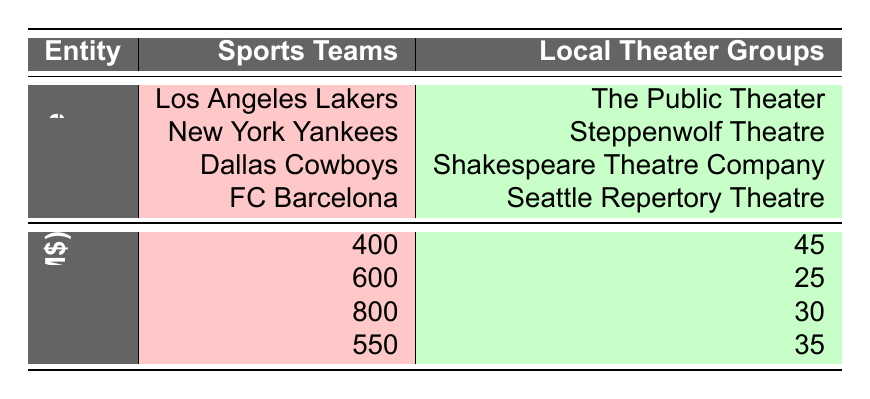What is the revenue of the New York Yankees in 2022? The table lists the revenue for each sports team, including the New York Yankees, which is shown as 600 million.
Answer: 600 million Which local theater group had the highest revenue in 2022? By examining the revenue values of local theater groups, The Public Theater has the highest revenue, totaling 45 million.
Answer: The Public Theater What is the combined revenue of the Dallas Cowboys and FC Barcelona? The revenue for the Dallas Cowboys is 800 million and for FC Barcelona is 550 million. Adding these gives 800 + 550 = 1350 million.
Answer: 1350 million Is the revenue of Steppenwolf Theatre greater than 30 million? The table shows the revenue for Steppenwolf Theatre as 25 million, which is less than 30 million. Thus, the answer is false.
Answer: False What is the average revenue of all sports teams listed? There are four sports teams with revenues of 400, 600, 800, and 550 million. The sum is 400 + 600 + 800 + 550 = 2350 million, and then dividing by 4, the average is 2350 / 4 = 587.5 million.
Answer: 587.5 million Which sports team has the largest revenue among the listed teams? By reviewing the revenues, the Dallas Cowboys at 800 million are identified as having the largest revenue compared to others.
Answer: Dallas Cowboys What is the difference in revenue between the New York Yankees and The Public Theater? The New York Yankees have a revenue of 600 million and The Public Theater has 45 million. The difference is 600 - 45 = 555 million.
Answer: 555 million Did FC Barcelona's revenue exceed 500 million in 2022? The revenue for FC Barcelona is reported as 550 million, which is indeed greater than 500 million. Hence, the answer is true.
Answer: True What is the total revenue of local theater groups listed in the table? Adding together the revenues of local theater groups: 45 + 25 + 30 + 35 gives a total of 135 million.
Answer: 135 million Which sports team has a revenue less than the combined revenue of Steppenwolf Theatre and Seattle Repertory Theatre? Steppenwolf Theatre has a revenue of 25 million and Seattle Repertory Theatre has 35 million, combined they total 60 million. The Los Angeles Lakers (400 million), New York Yankees (600 million), and FC Barcelona (550 million) all have revenues greater than 60 million. Thus, none of the teams listed have revenue less than this combined amount.
Answer: None 